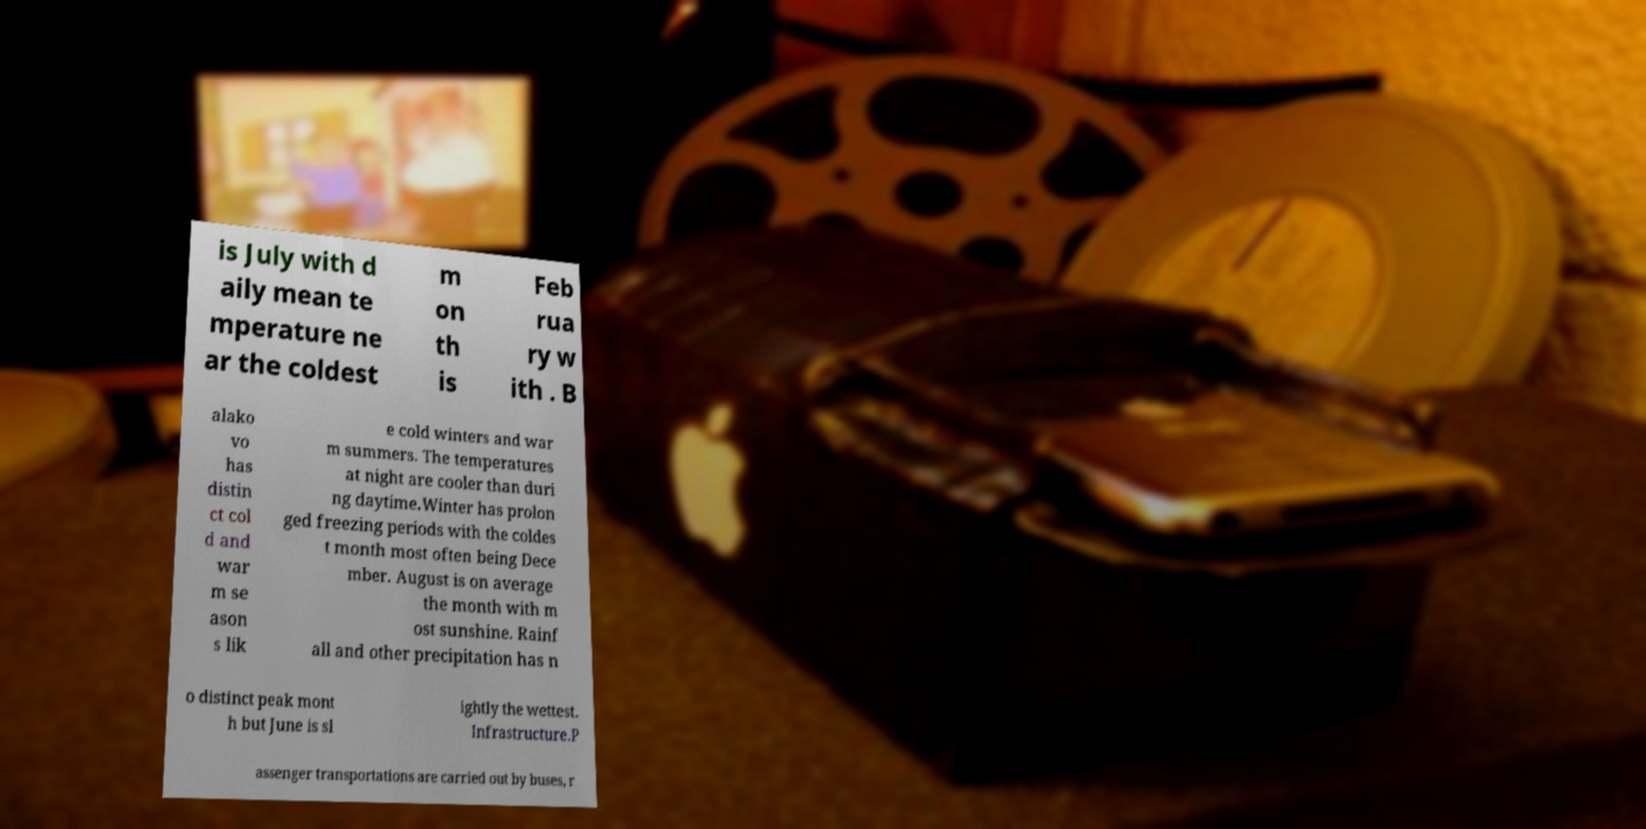I need the written content from this picture converted into text. Can you do that? is July with d aily mean te mperature ne ar the coldest m on th is Feb rua ry w ith . B alako vo has distin ct col d and war m se ason s lik e cold winters and war m summers. The temperatures at night are cooler than duri ng daytime.Winter has prolon ged freezing periods with the coldes t month most often being Dece mber. August is on average the month with m ost sunshine. Rainf all and other precipitation has n o distinct peak mont h but June is sl ightly the wettest. Infrastructure.P assenger transportations are carried out by buses, r 